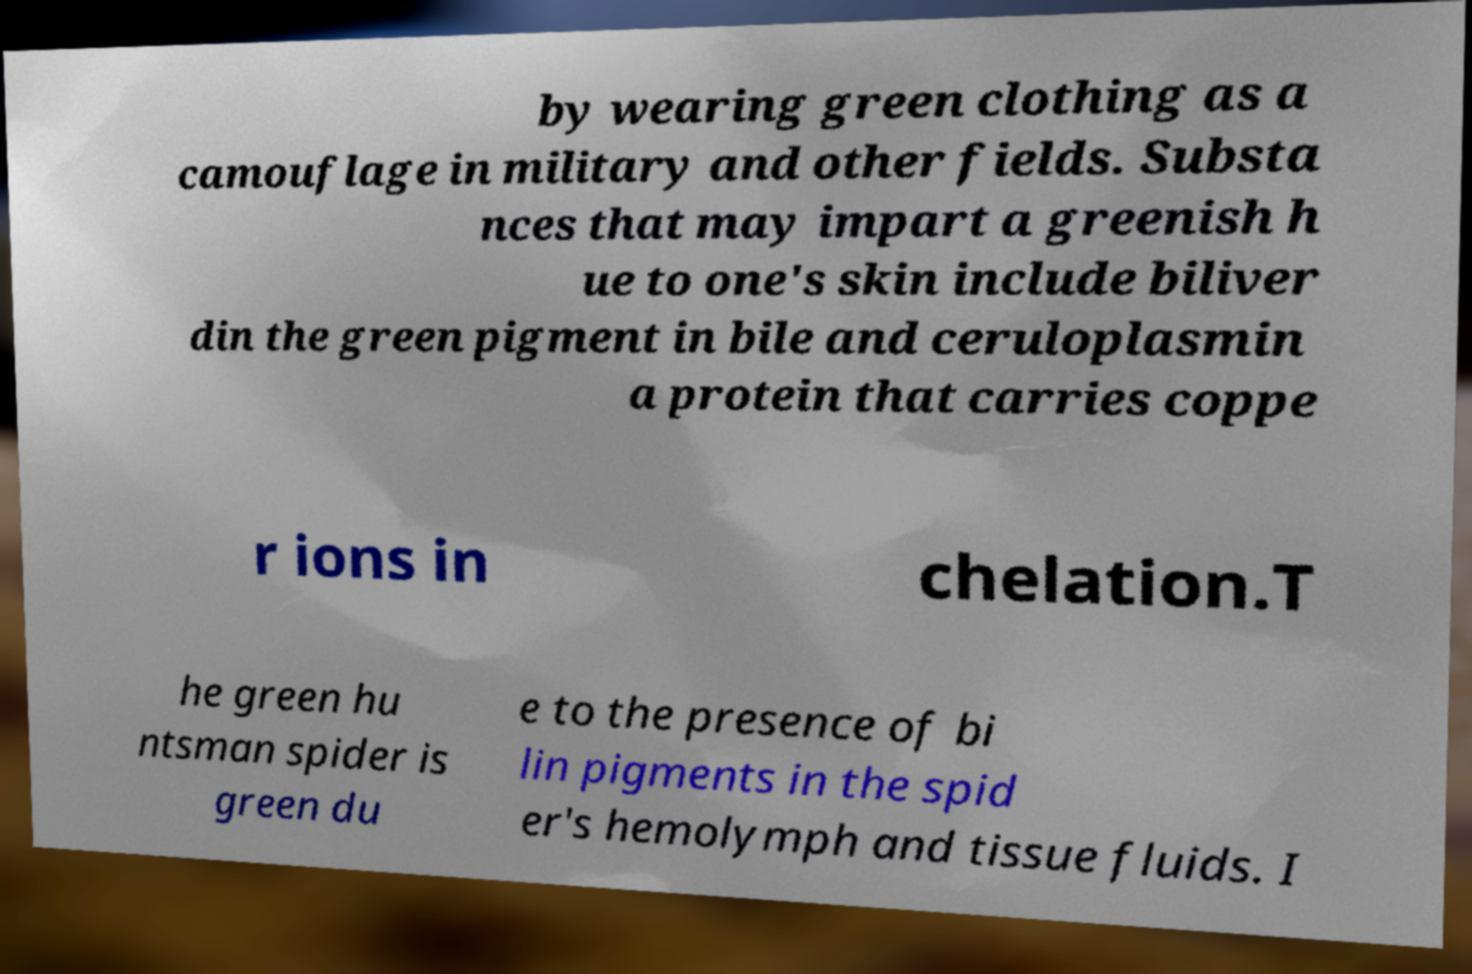Please read and relay the text visible in this image. What does it say? by wearing green clothing as a camouflage in military and other fields. Substa nces that may impart a greenish h ue to one's skin include biliver din the green pigment in bile and ceruloplasmin a protein that carries coppe r ions in chelation.T he green hu ntsman spider is green du e to the presence of bi lin pigments in the spid er's hemolymph and tissue fluids. I 